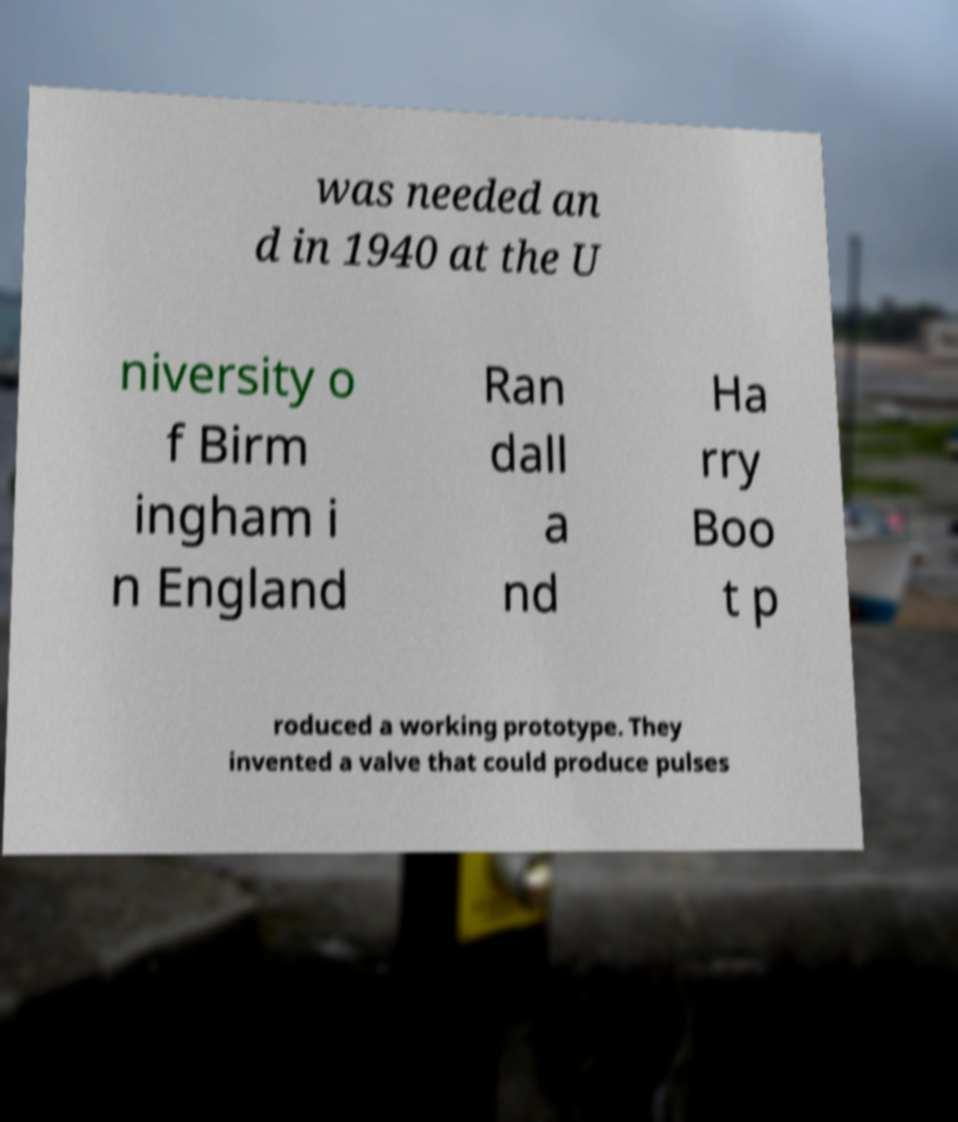Could you assist in decoding the text presented in this image and type it out clearly? was needed an d in 1940 at the U niversity o f Birm ingham i n England Ran dall a nd Ha rry Boo t p roduced a working prototype. They invented a valve that could produce pulses 